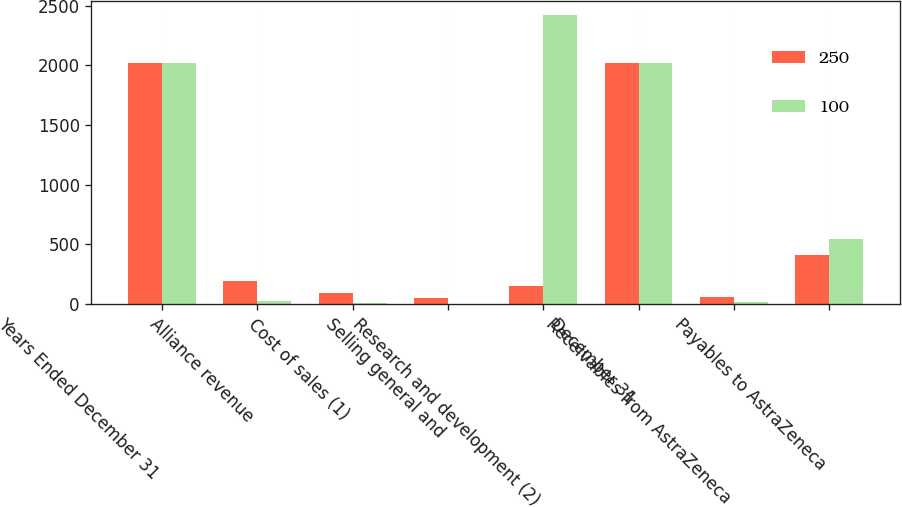Convert chart to OTSL. <chart><loc_0><loc_0><loc_500><loc_500><stacked_bar_chart><ecel><fcel>Years Ended December 31<fcel>Alliance revenue<fcel>Cost of sales (1)<fcel>Selling general and<fcel>Research and development (2)<fcel>December 31<fcel>Receivables from AstraZeneca<fcel>Payables to AstraZeneca<nl><fcel>250<fcel>2018<fcel>187<fcel>93<fcel>48<fcel>152<fcel>2018<fcel>52<fcel>405<nl><fcel>100<fcel>2017<fcel>20<fcel>4<fcel>1<fcel>2419<fcel>2017<fcel>12<fcel>543<nl></chart> 